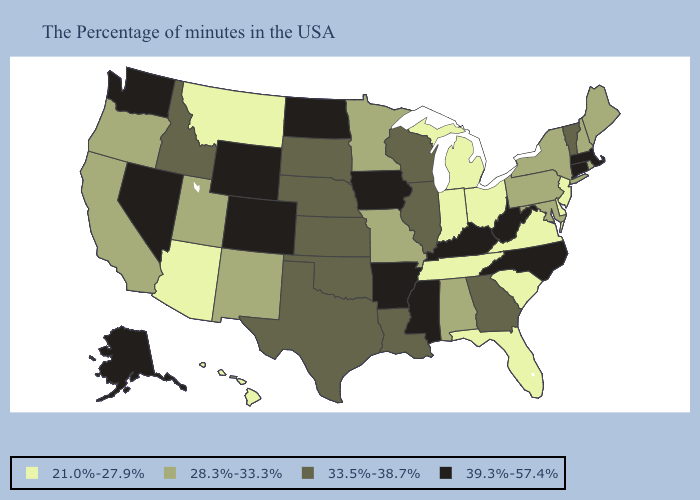Does the first symbol in the legend represent the smallest category?
Short answer required. Yes. Does Rhode Island have the highest value in the Northeast?
Write a very short answer. No. Does Pennsylvania have a lower value than Delaware?
Short answer required. No. What is the value of Delaware?
Write a very short answer. 21.0%-27.9%. Name the states that have a value in the range 39.3%-57.4%?
Be succinct. Massachusetts, Connecticut, North Carolina, West Virginia, Kentucky, Mississippi, Arkansas, Iowa, North Dakota, Wyoming, Colorado, Nevada, Washington, Alaska. What is the value of Ohio?
Give a very brief answer. 21.0%-27.9%. Name the states that have a value in the range 21.0%-27.9%?
Concise answer only. New Jersey, Delaware, Virginia, South Carolina, Ohio, Florida, Michigan, Indiana, Tennessee, Montana, Arizona, Hawaii. What is the highest value in the USA?
Write a very short answer. 39.3%-57.4%. Among the states that border Iowa , does South Dakota have the lowest value?
Give a very brief answer. No. Name the states that have a value in the range 33.5%-38.7%?
Quick response, please. Vermont, Georgia, Wisconsin, Illinois, Louisiana, Kansas, Nebraska, Oklahoma, Texas, South Dakota, Idaho. What is the lowest value in the South?
Answer briefly. 21.0%-27.9%. What is the value of Kansas?
Short answer required. 33.5%-38.7%. What is the value of Oregon?
Short answer required. 28.3%-33.3%. Name the states that have a value in the range 33.5%-38.7%?
Be succinct. Vermont, Georgia, Wisconsin, Illinois, Louisiana, Kansas, Nebraska, Oklahoma, Texas, South Dakota, Idaho. Name the states that have a value in the range 28.3%-33.3%?
Quick response, please. Maine, Rhode Island, New Hampshire, New York, Maryland, Pennsylvania, Alabama, Missouri, Minnesota, New Mexico, Utah, California, Oregon. 